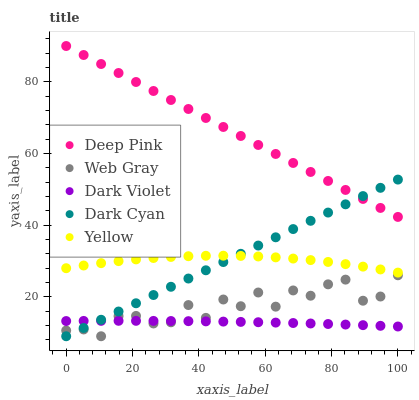Does Dark Violet have the minimum area under the curve?
Answer yes or no. Yes. Does Deep Pink have the maximum area under the curve?
Answer yes or no. Yes. Does Web Gray have the minimum area under the curve?
Answer yes or no. No. Does Web Gray have the maximum area under the curve?
Answer yes or no. No. Is Dark Cyan the smoothest?
Answer yes or no. Yes. Is Web Gray the roughest?
Answer yes or no. Yes. Is Deep Pink the smoothest?
Answer yes or no. No. Is Deep Pink the roughest?
Answer yes or no. No. Does Dark Cyan have the lowest value?
Answer yes or no. Yes. Does Deep Pink have the lowest value?
Answer yes or no. No. Does Deep Pink have the highest value?
Answer yes or no. Yes. Does Web Gray have the highest value?
Answer yes or no. No. Is Web Gray less than Deep Pink?
Answer yes or no. Yes. Is Yellow greater than Web Gray?
Answer yes or no. Yes. Does Yellow intersect Dark Cyan?
Answer yes or no. Yes. Is Yellow less than Dark Cyan?
Answer yes or no. No. Is Yellow greater than Dark Cyan?
Answer yes or no. No. Does Web Gray intersect Deep Pink?
Answer yes or no. No. 